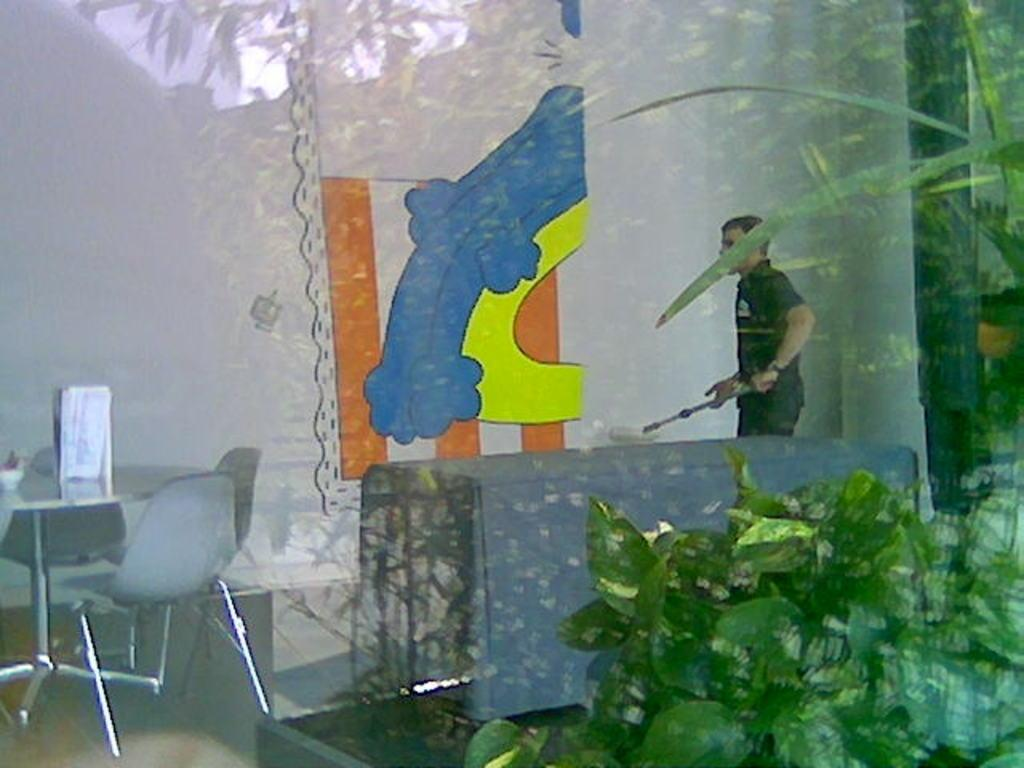Who is present in the image? There is a man in the image. What is the man wearing? The man is wearing a black t-shirt. What is the man holding in the image? The man is holding a stick. What type of furniture can be seen in the image? There is a table and chairs in the image. What type of vegetation is present in the image? There are plants in the image. What type of object made of glass can be seen in the image? There is a glass object in the image. What is the weight of the straw in the image? There is no straw present in the image, so it is not possible to determine its weight. 